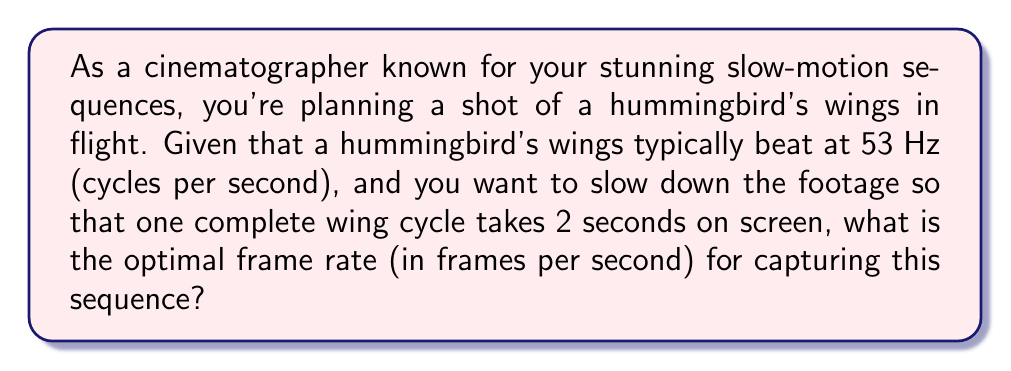Could you help me with this problem? Let's approach this step-by-step:

1) First, we need to understand what we're trying to achieve:
   - The hummingbird's wings beat at 53 Hz (53 cycles per second)
   - We want one cycle to last 2 seconds on screen

2) Let's define some variables:
   - Let $f$ be the frame rate we're looking for (in frames per second)
   - Let $t$ be the playback speed factor (how much we're slowing down the footage)

3) We can express the relationship between real-time and slow-motion as:
   $$ t = \frac{2 \text{ seconds on screen}}{1/53 \text{ seconds in reality}} = 2 \times 53 = 106 $$

4) This means we're slowing down the footage by a factor of 106.

5) To determine the frame rate, we need to multiply the playback speed factor by the original frequency:
   $$ f = t \times 53 \text{ Hz} = 106 \times 53 \text{ fps} = 5,618 \text{ fps} $$

6) Therefore, to capture the hummingbird's wing motion so that one cycle takes 2 seconds when played back, we need to shoot at 5,618 frames per second.
Answer: 5,618 fps 